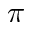Convert formula to latex. <formula><loc_0><loc_0><loc_500><loc_500>\pi</formula> 